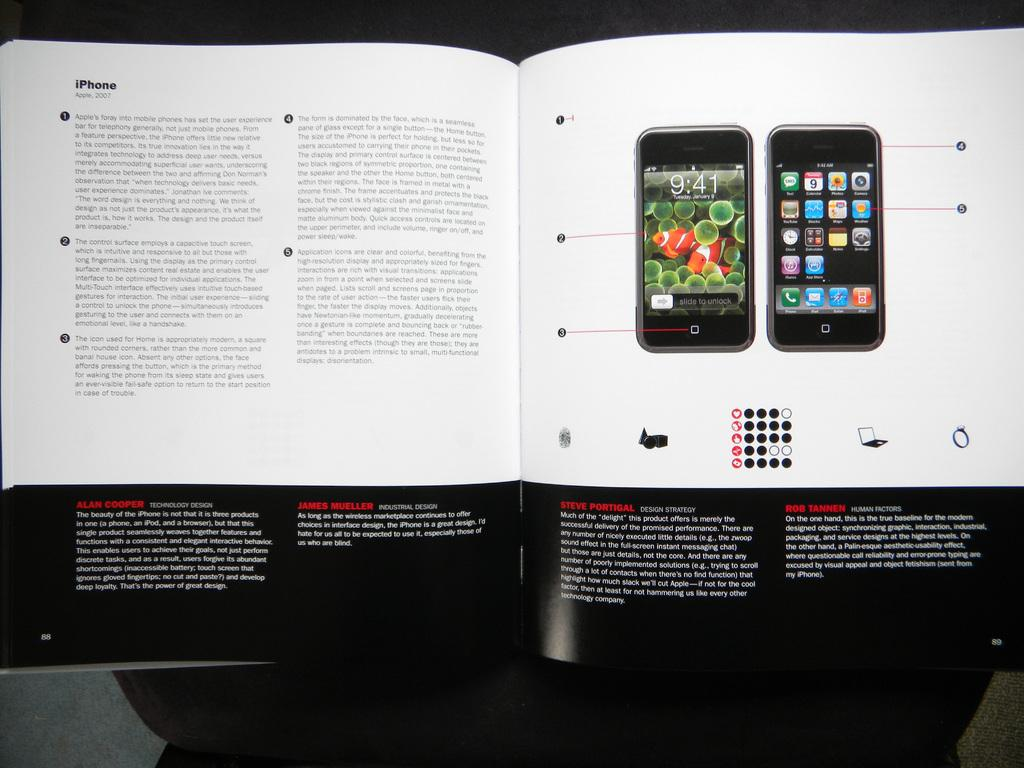<image>
Describe the image concisely. A booklet is open to a spread titled iPhone, Apple 2017 and shows features of the phone. 